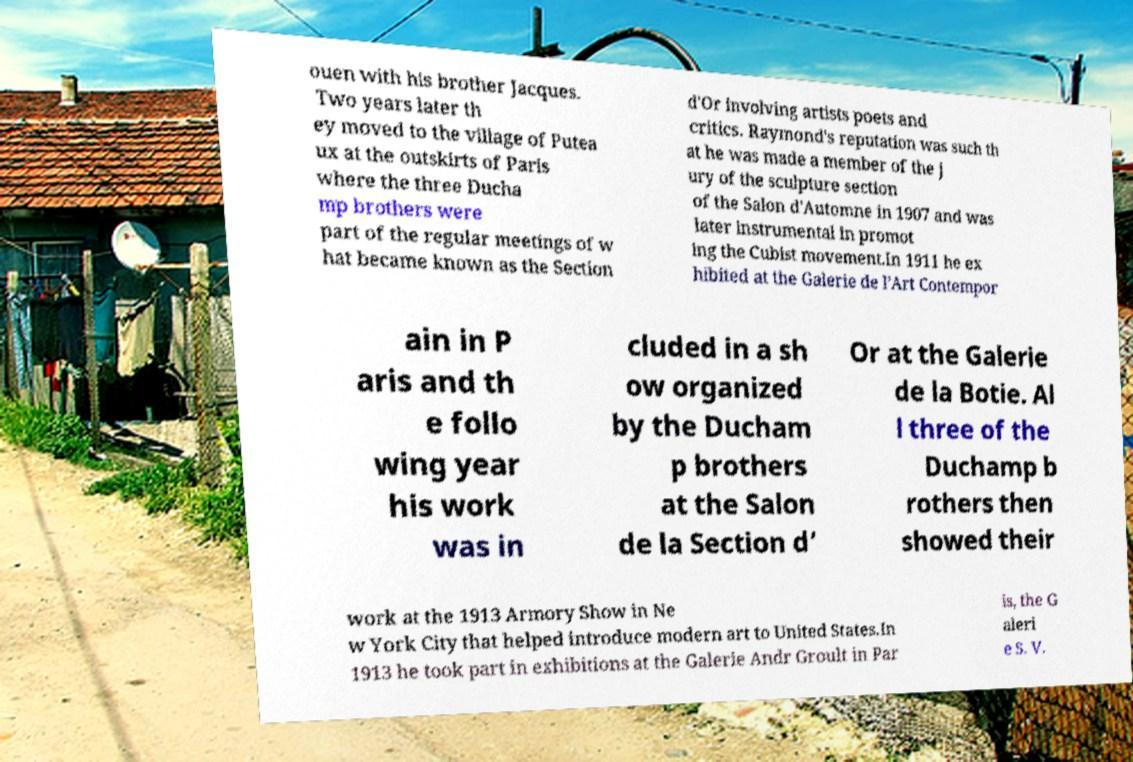Please identify and transcribe the text found in this image. ouen with his brother Jacques. Two years later th ey moved to the village of Putea ux at the outskirts of Paris where the three Ducha mp brothers were part of the regular meetings of w hat became known as the Section d'Or involving artists poets and critics. Raymond's reputation was such th at he was made a member of the j ury of the sculpture section of the Salon d'Automne in 1907 and was later instrumental in promot ing the Cubist movement.In 1911 he ex hibited at the Galerie de l’Art Contempor ain in P aris and th e follo wing year his work was in cluded in a sh ow organized by the Ducham p brothers at the Salon de la Section d’ Or at the Galerie de la Botie. Al l three of the Duchamp b rothers then showed their work at the 1913 Armory Show in Ne w York City that helped introduce modern art to United States.In 1913 he took part in exhibitions at the Galerie Andr Groult in Par is, the G aleri e S. V. 